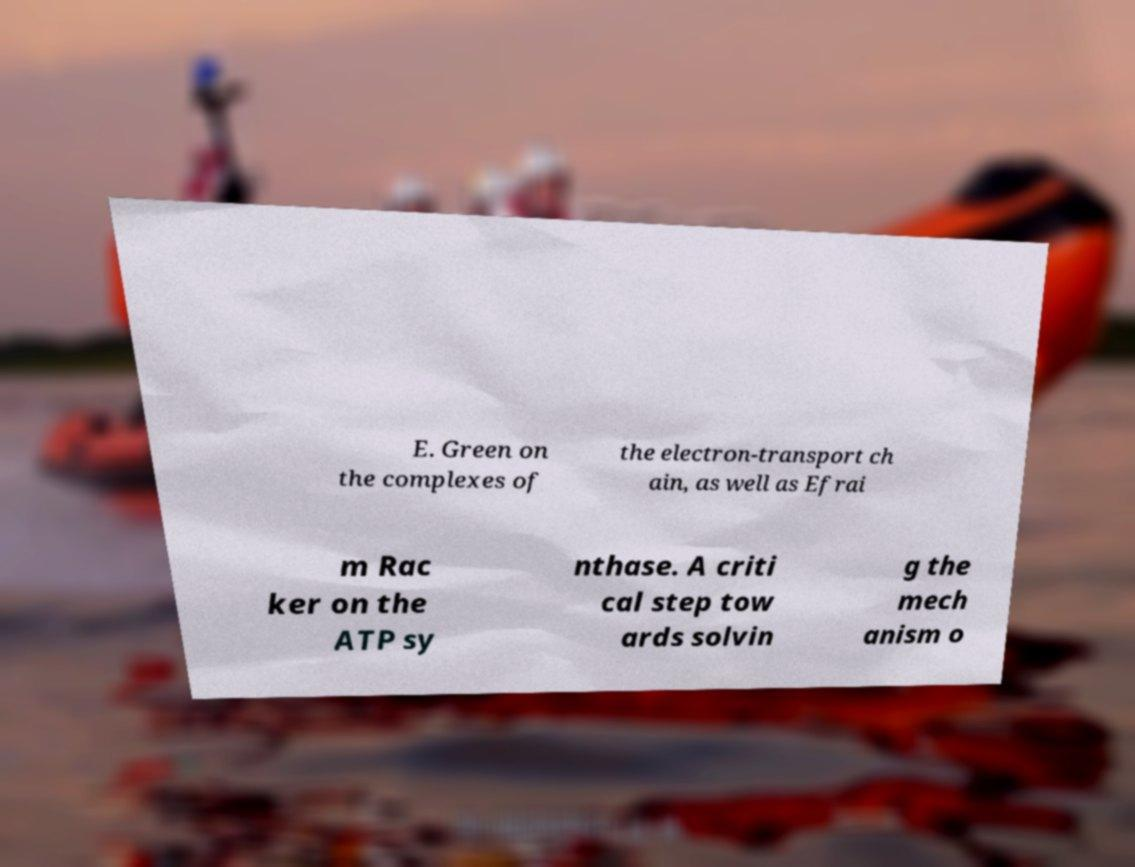What messages or text are displayed in this image? I need them in a readable, typed format. E. Green on the complexes of the electron-transport ch ain, as well as Efrai m Rac ker on the ATP sy nthase. A criti cal step tow ards solvin g the mech anism o 